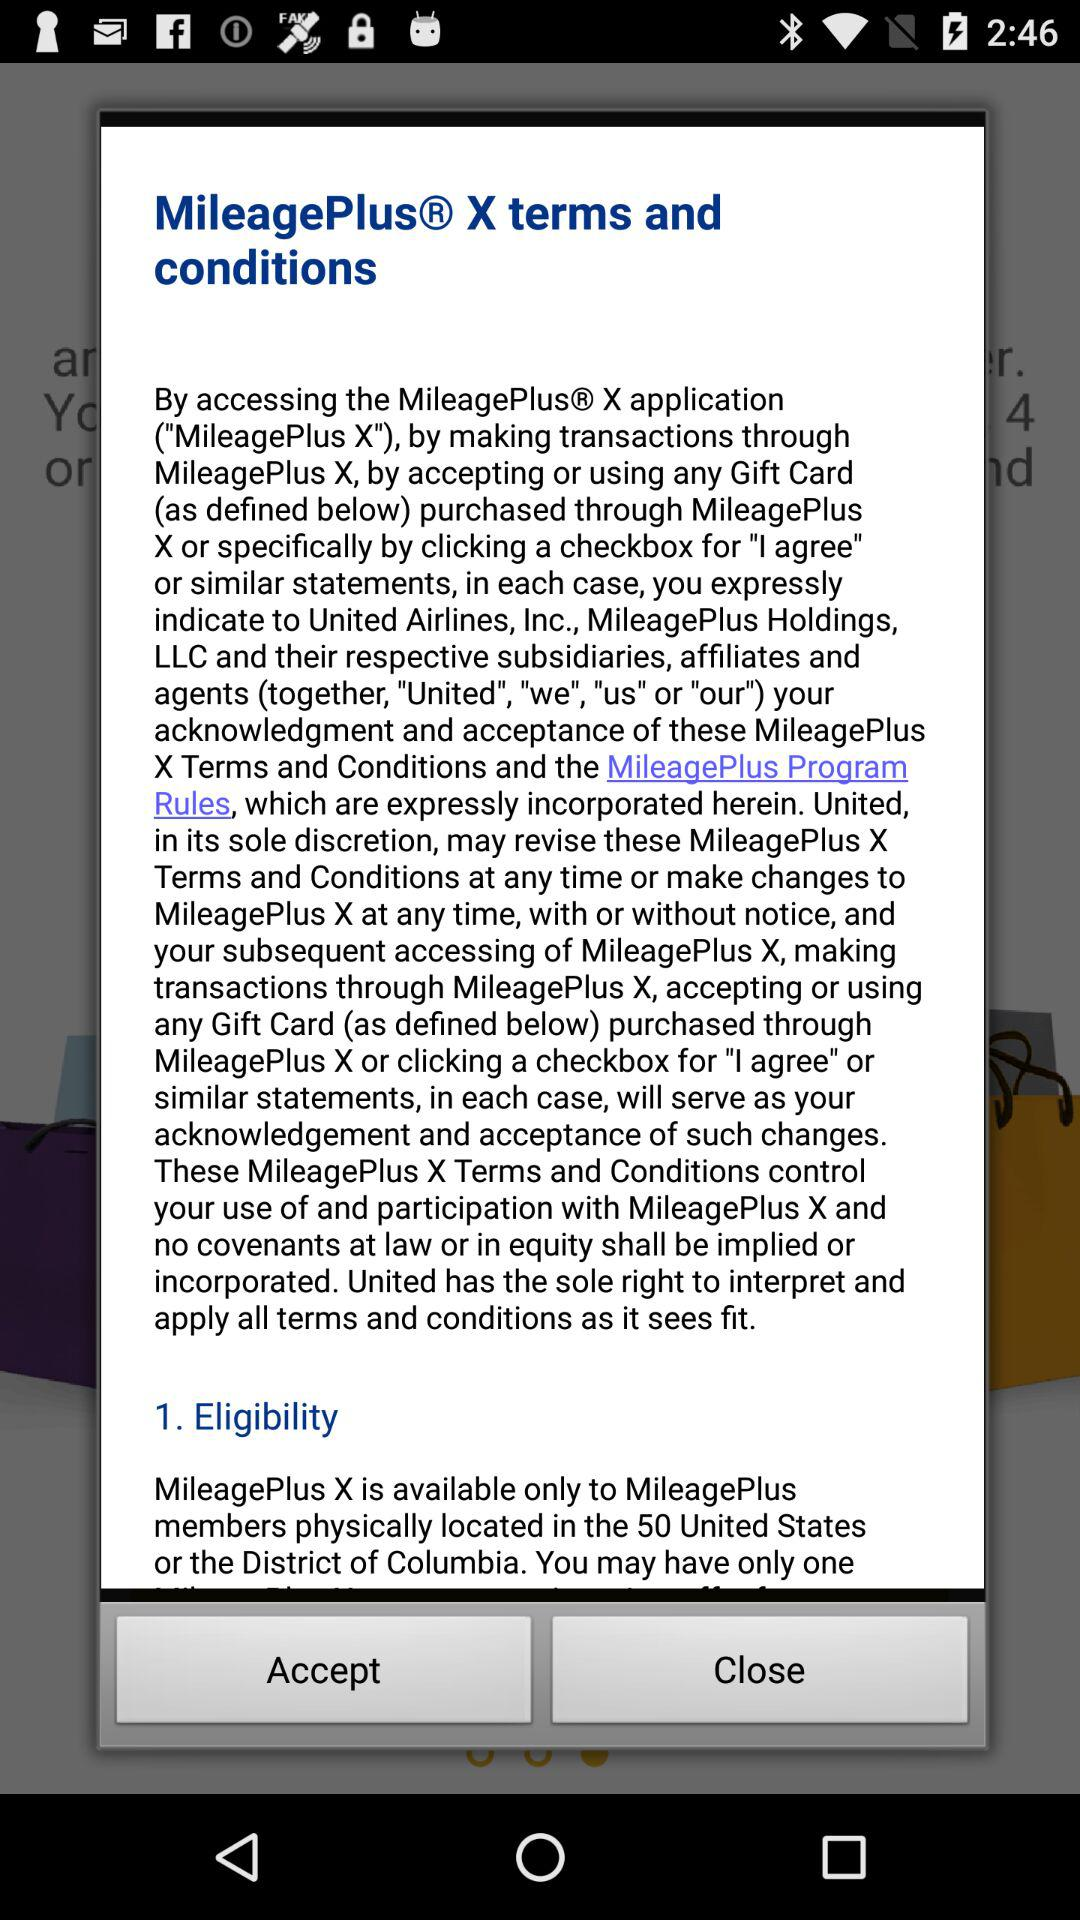What is the name of the application? The name of the application is "MileagePlus X". 